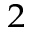Convert formula to latex. <formula><loc_0><loc_0><loc_500><loc_500>^ { 2 }</formula> 